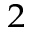Convert formula to latex. <formula><loc_0><loc_0><loc_500><loc_500>^ { 2 }</formula> 